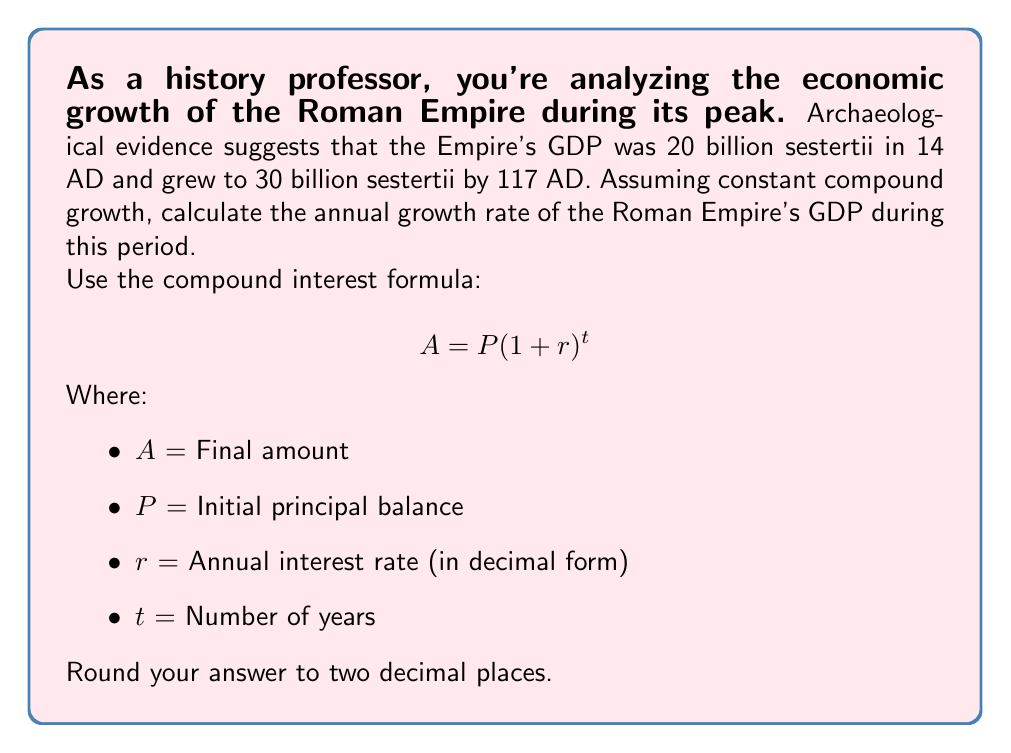Solve this math problem. Let's approach this step-by-step:

1) First, identify the known variables:
   P = 20 billion sestertii (initial GDP in 14 AD)
   A = 30 billion sestertii (final GDP in 117 AD)
   t = 117 - 14 = 103 years

2) We need to solve for r (the annual growth rate).

3) Plug these values into the compound interest formula:

   $$ 30 = 20(1 + r)^{103} $$

4) Divide both sides by 20:

   $$ \frac{30}{20} = (1 + r)^{103} $$

5) Simplify:

   $$ 1.5 = (1 + r)^{103} $$

6) Take the 103rd root of both sides:

   $$ \sqrt[103]{1.5} = 1 + r $$

7) Subtract 1 from both sides:

   $$ \sqrt[103]{1.5} - 1 = r $$

8) Calculate this value and convert to a percentage:

   $$ r = (\sqrt[103]{1.5} - 1) * 100 \approx 0.3969\% $$

9) Round to two decimal places: 0.40%
Answer: 0.40% 